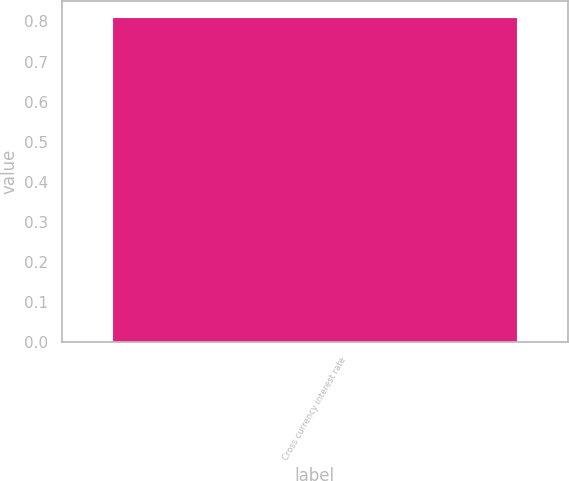<chart> <loc_0><loc_0><loc_500><loc_500><bar_chart><fcel>Cross currency interest rate<nl><fcel>0.81<nl></chart> 